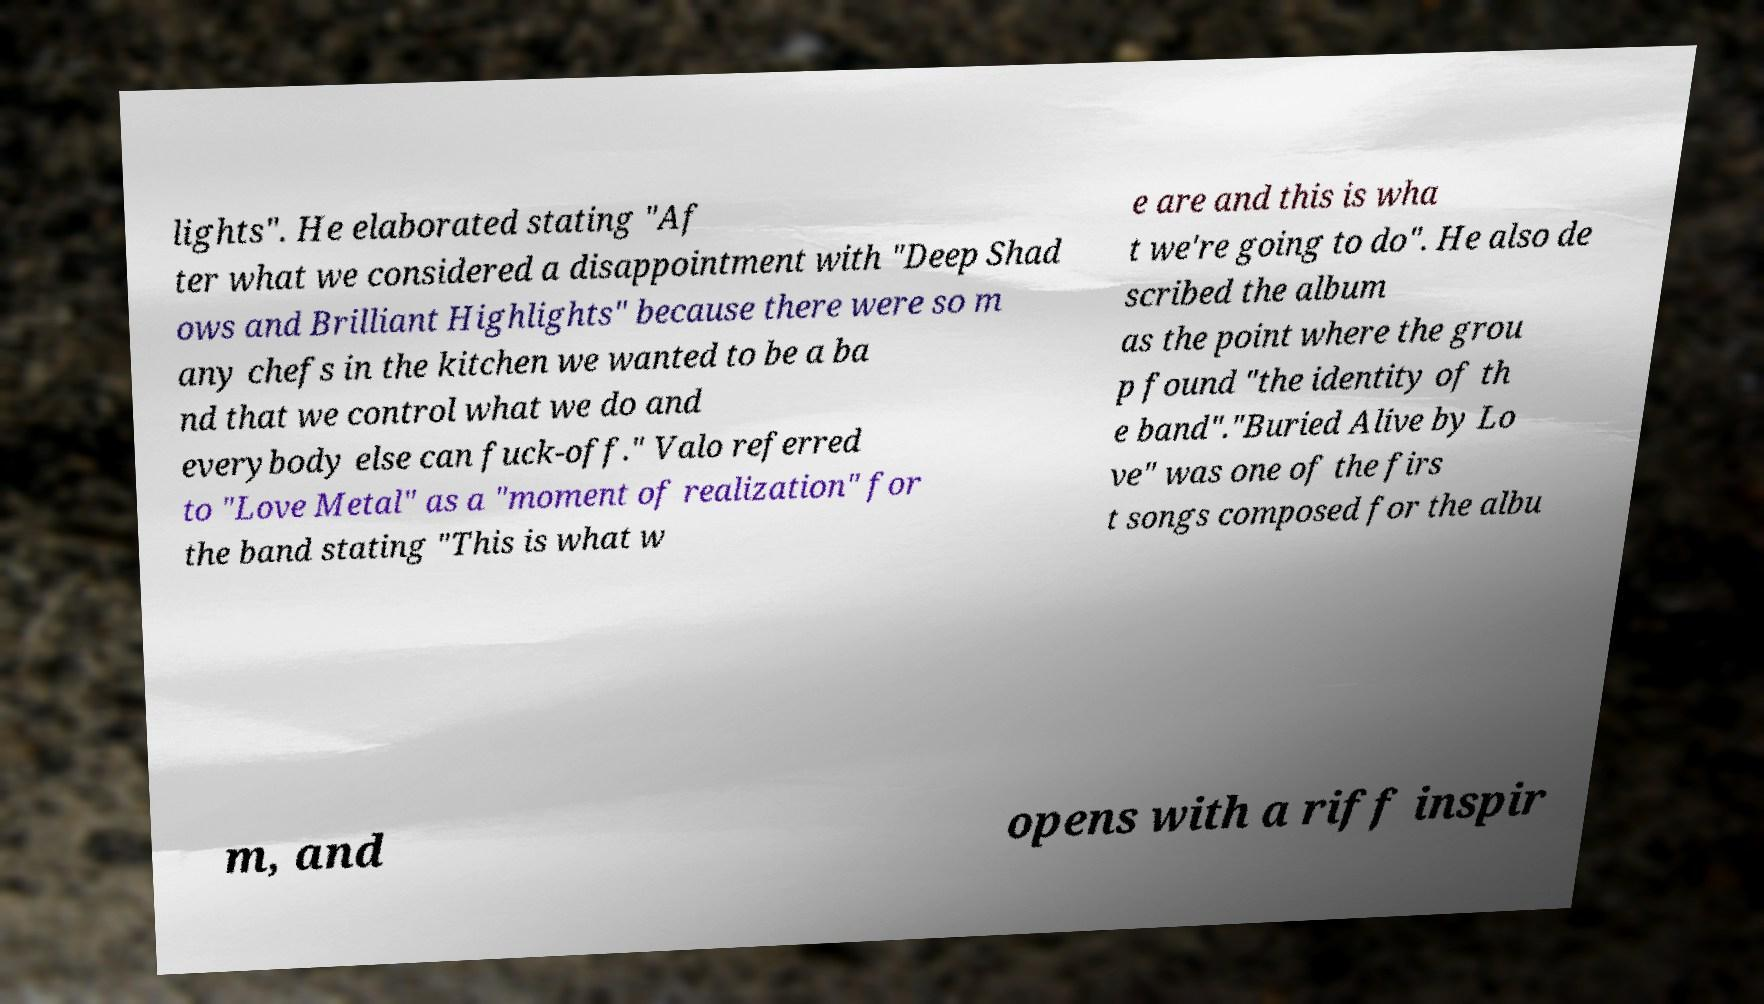There's text embedded in this image that I need extracted. Can you transcribe it verbatim? lights". He elaborated stating "Af ter what we considered a disappointment with "Deep Shad ows and Brilliant Highlights" because there were so m any chefs in the kitchen we wanted to be a ba nd that we control what we do and everybody else can fuck-off." Valo referred to "Love Metal" as a "moment of realization" for the band stating "This is what w e are and this is wha t we're going to do". He also de scribed the album as the point where the grou p found "the identity of th e band"."Buried Alive by Lo ve" was one of the firs t songs composed for the albu m, and opens with a riff inspir 